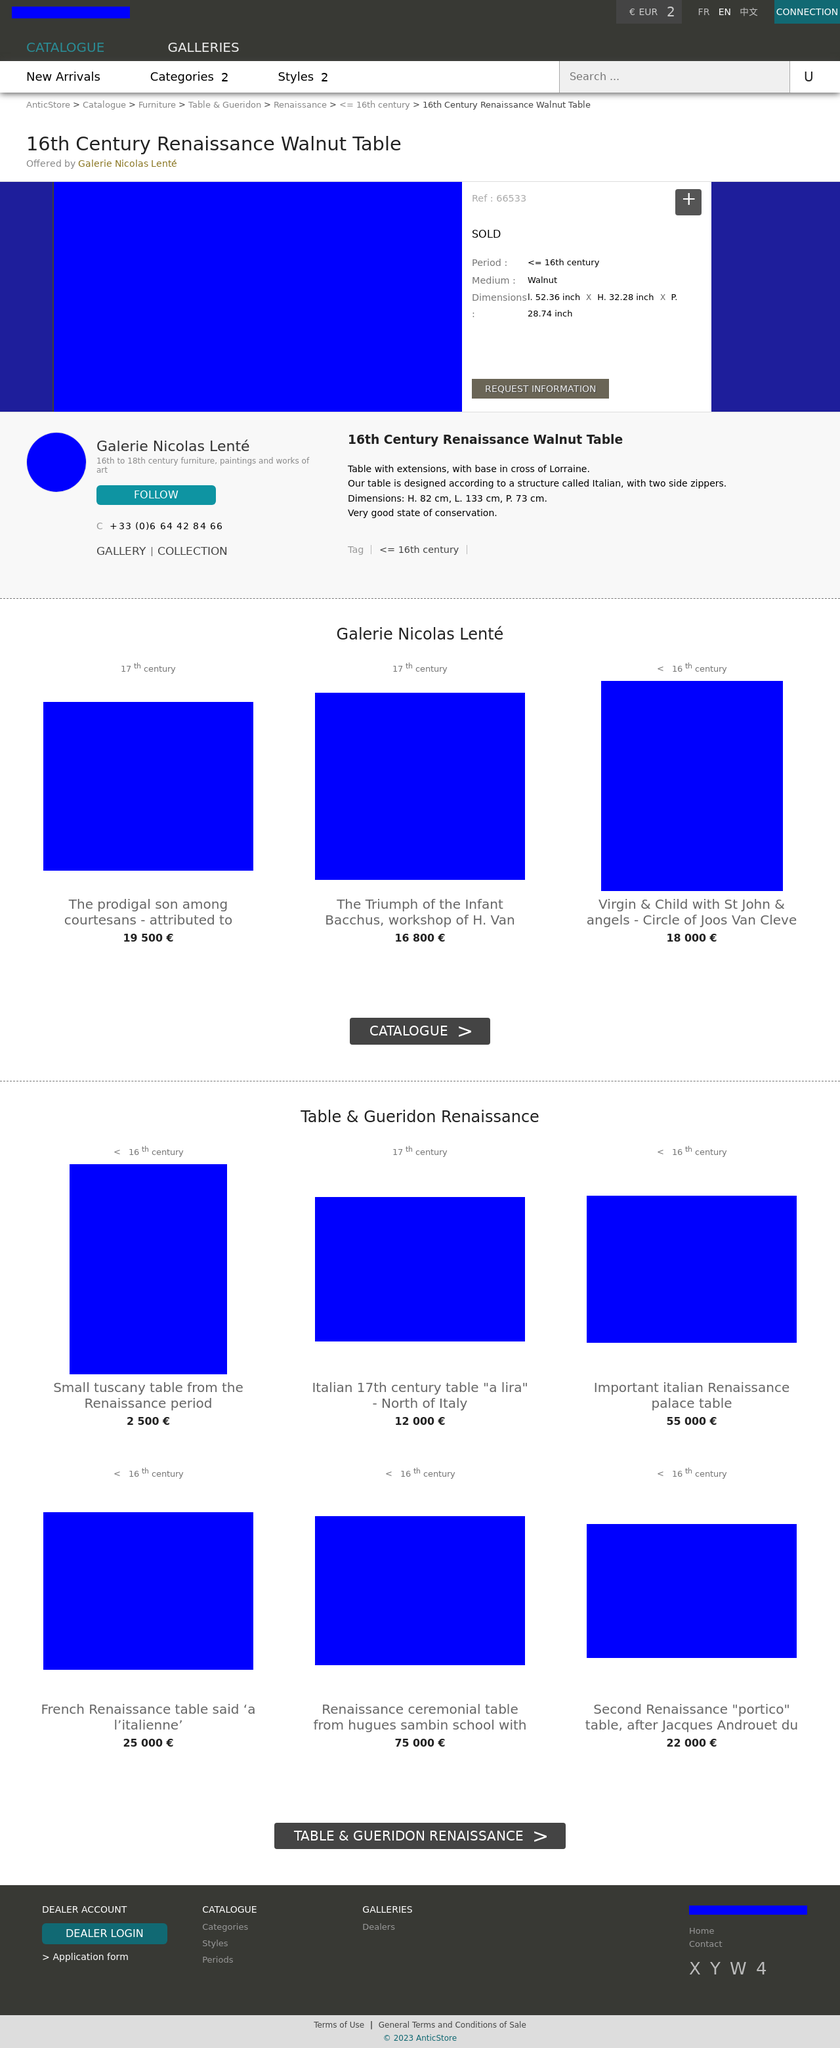Can you tell me more about the 16th Century Renaissance Walnut Table featured on this part of the website? Certainly! The 16th Century Renaissance Walnut Table is an exquisite piece of furniture with historical significance. Its design includes a base in the shape of the cross of Lorraine and two side zippers, characteristics of Italian structured furniture from that era. The table measures 82 cm in height, 133 cm in length, and 73 cm in depth, and is in a very good state of conservation, making it a valuable item for collectors and enthusiasts of Renaissance period furniture. 